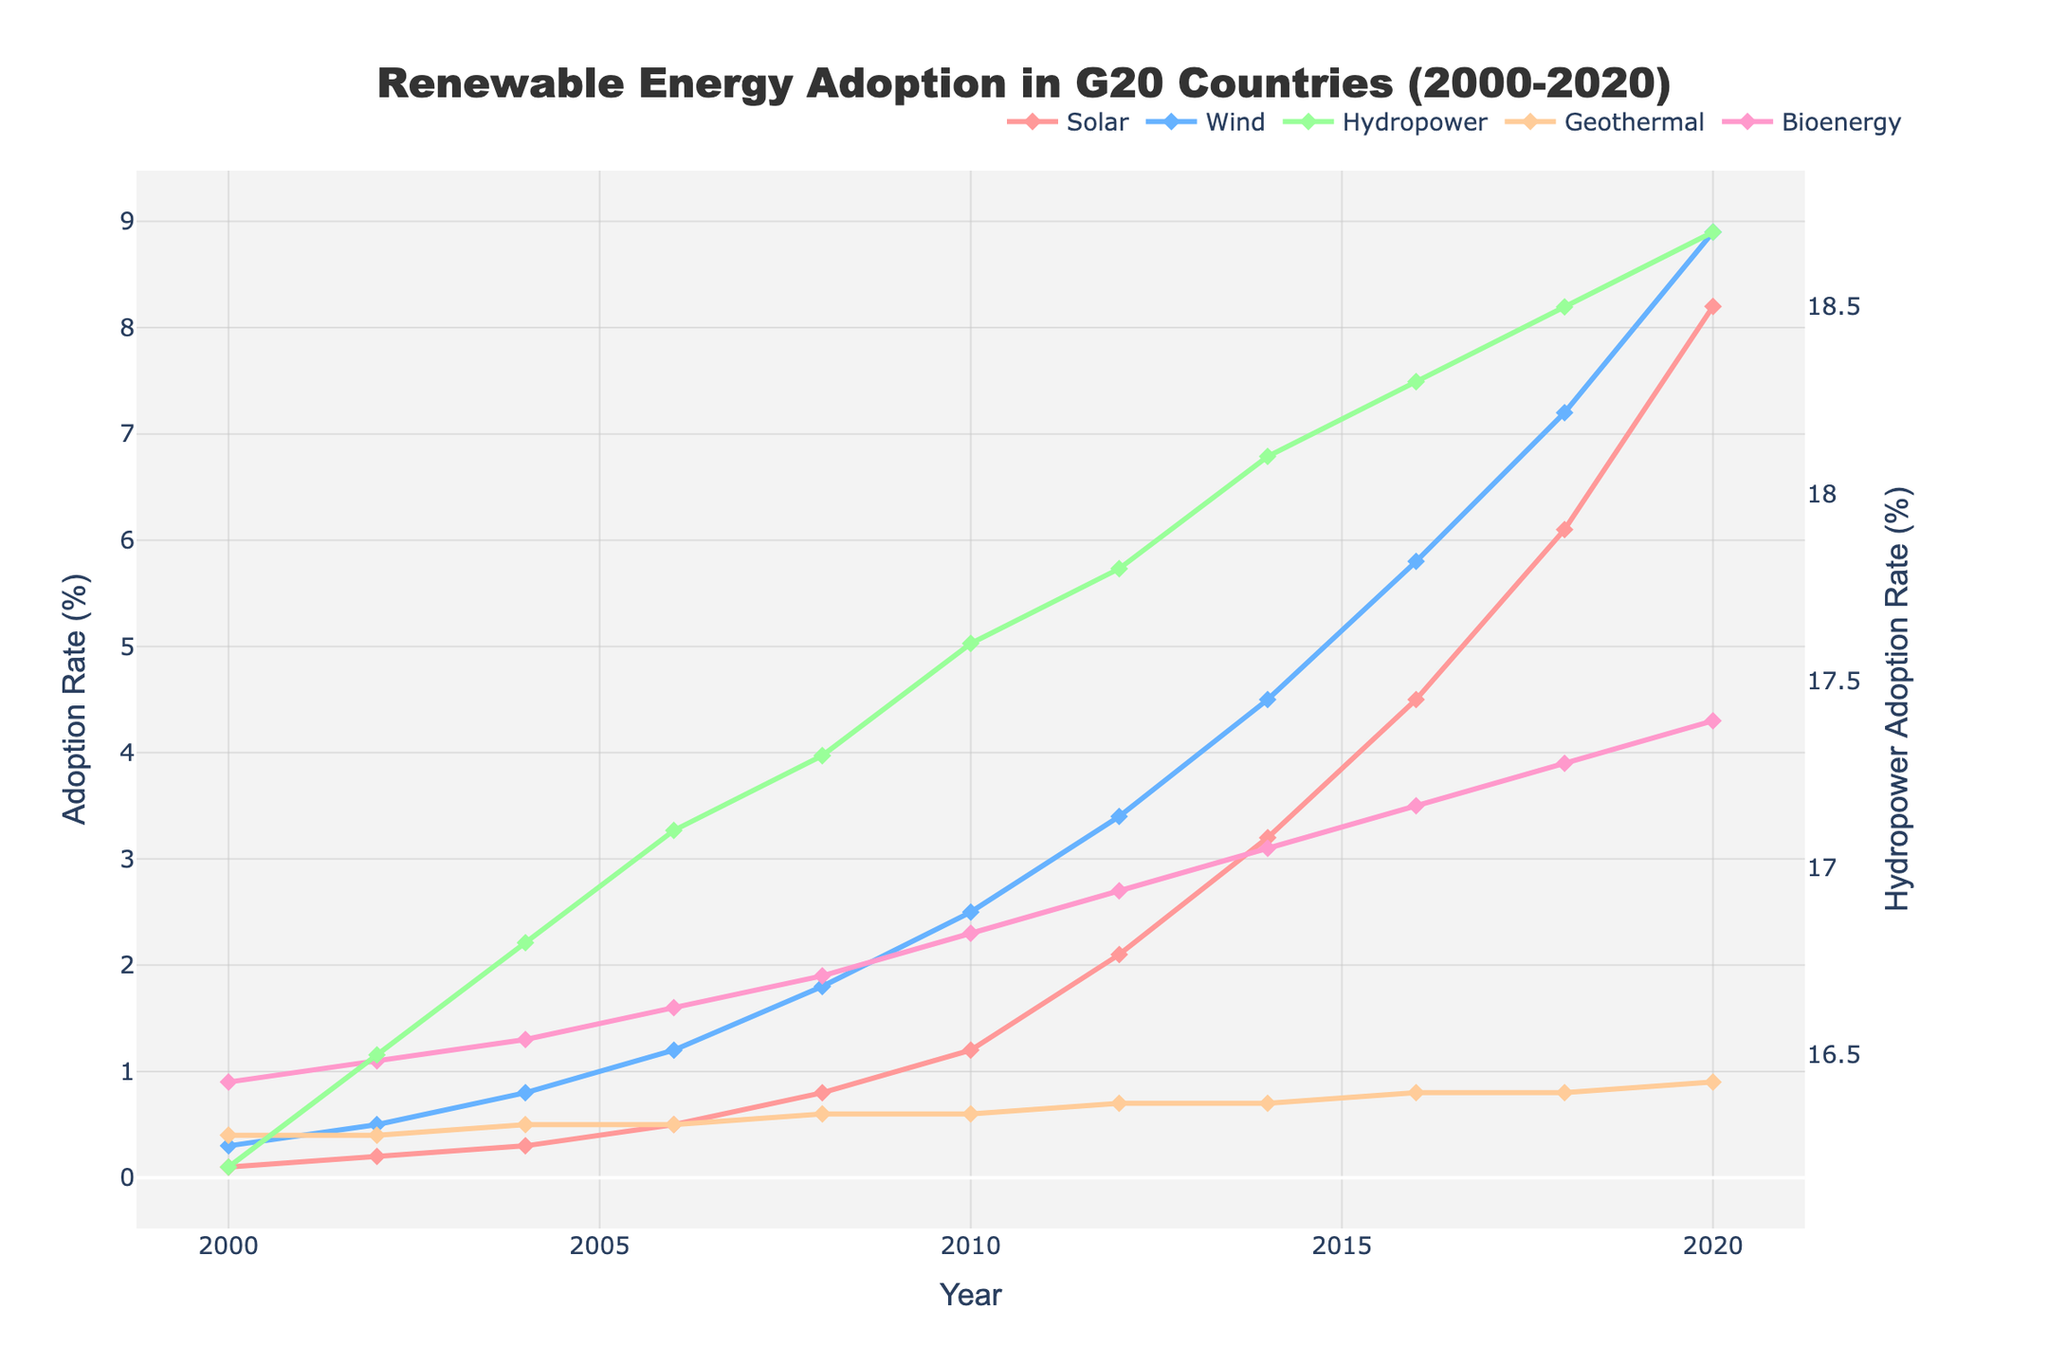What type of renewable energy saw the highest adoption rate in 2020? The figure shows that in 2020, Hydropower has the highest adoption rate compared to Solar, Wind, Geothermal, and Bioenergy.
Answer: Hydropower How much did the adoption rate of Solar energy increase from 2000 to 2020? The adoption rate of Solar energy in 2000 was 0.1%, and it increased to 8.2% in 2020. The increase is calculated by subtracting the 2000 value from the 2020 value, thus 8.2 - 0.1 = 8.1%.
Answer: 8.1% Which energy type experienced the most significant growth in adoption rate from 2000 to 2020? By inspecting the lines, it is clear that Solar energy experienced the most significant growth. Its adoption rate went from 0.1% in 2000 to 8.2% in 2020, which is the largest absolute increase compared to other energy types.
Answer: Solar In which year did Wind energy adoption surpass 2%? The figure shows the Wind energy adoption rate crossing 2% between 2008 and 2010. By referring to the closest data point, it is apparent that in 2010 the adoption rate was 2.5%.
Answer: 2010 Compare the adoption rates of Geothermal and Bioenergy in 2020. Which one had a higher rate and by how much? In 2020, the Geothermal energy adoption rate was 0.9% and Bioenergy was 4.3%. Subtracting these values, Bioenergy's adoption rate was higher by 4.3% - 0.9% = 3.4%.
Answer: Bioenergy by 3.4% Which renewable energy type had the lowest adoption rate in 2008? By comparing adoption rates for all energy types in 2008, it is clear that Geothermal had the lowest rate at 0.6%.
Answer: Geothermal How did the adoption rate of Wind energy change from 2012 to 2014? In 2012, Wind energy had an adoption rate of 3.4%, and in 2014 it was 4.5%. The change is calculated as 4.5% - 3.4% = 1.1%.
Answer: Increased by 1.1% What is the combined adoption rate of Solar and Wind energy in 2016? By summing the adoption rates of Solar (4.5%) and Wind (5.8%) in 2016, the combined rate is 4.5% + 5.8% = 10.3%.
Answer: 10.3% Which year shows the smallest adoption rate difference between Hydropower and Bioenergy? The smallest difference can be found by comparing the adoption rates of Hydropower and Bioenergy year by year. In 2000, the difference is 16.2% - 0.9% = 15.3%; in 2020, it is 18.7% - 4.3% = 14.4%. Continue this for each year, and we find that 2018 has the smallest difference at 18.5% - 3.9% = 14.6%.
Answer: 2018 